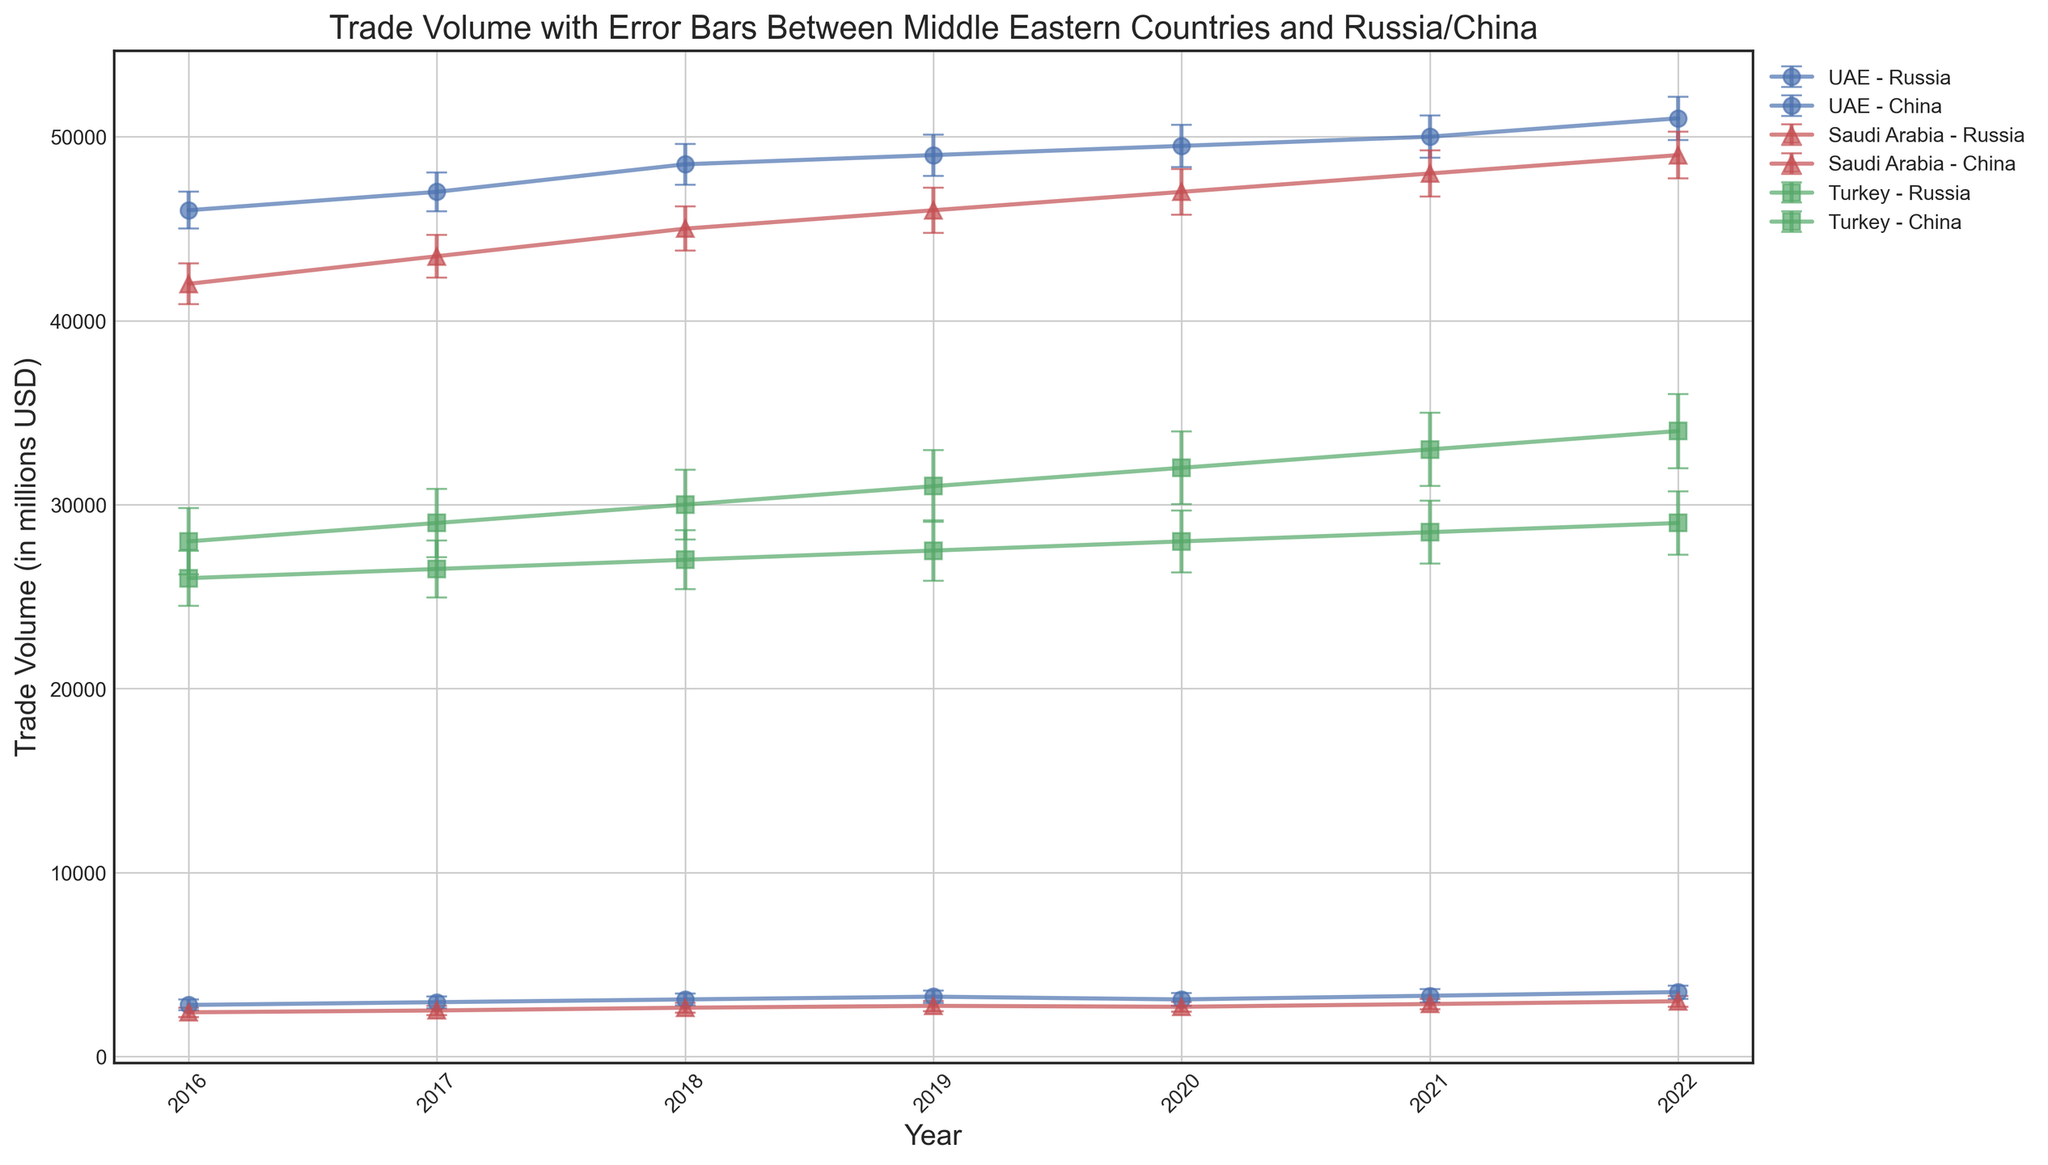Which country showed the largest trade volume with China in 2019? By inspecting the chart for 2019, we compare the trade volumes with China for UAE, Saudi Arabia, and Turkey. The UAE has around 49,000, Saudi Arabia around 46,000, and Turkey around 31,000. Thus, the UAE showed the largest trade volume with China in 2019.
Answer: UAE How does the trade volume with Russia for Saudi Arabia in 2018 compare to 2022? By comparing the trade volumes for Saudi Arabia and Russia in these years, we see that in 2018 it was around 2,650, whereas in 2022 it was around 3,000. This means there was an increase of approximately 350.
Answer: Increase by 350 What is the total trade volume between Turkey and both partners (Russia and China) in 2020? Inspect the chart for Turkey in 2020. The trade volumes with Russia and China were about 28,000 and 32,000 respectively. Summing these gives a total of 28,000 + 32,000 = 60,000.
Answer: 60,000 Which country had the smallest error margin in trading with Russia in 2021? Check the error bars for UAE, Saudi Arabia, and Turkey trading with Russia in 2021. The smallest error bar appears to be Saudi Arabia with an error margin of around 290.
Answer: Saudi Arabia During which year did UAE's trade volume with Russia reach its highest value within the given dataset? By observing the UAE's trade volumes with Russia across the years, the highest volume appears in 2022 with around 3,500.
Answer: 2022 What is the average trade volume for Saudi Arabia with China from 2016 to 2022? Calculate the average by summing the trade volumes from 2016 to 2022 (42,000 + 43,500 + 45,000 + 46,000 + 47,000 + 48,000 + 49,000) and dividing by the number of years (7). The total is 320,500, so the average is 320,500 / 7 = 45,785.71.
Answer: 45,785.71 How does the trend in trade volume between UAE and China compare to that between UAE and Russia from 2016 to 2022? Analyze the trends for both UAE-China and UAE-Russia. UAE-China shows a consistently increasing trend from 46,000 to 51,000, while UAE-Russia also shows an increasing trend but starts much lower at 2,800 and reaches 3,500. Both trends are upward, but the magnitude of trade volume with China is significantly higher.
Answer: Both increase; trade with China is higher Which country showed more stability in trade volume with Russia, considering the error bars, between 2016 and 2022? By examining the error bars for UAE, Saudi Arabia, and Turkey with Russia, Saudi Arabia consistently has smaller error margins compared to UAE and Turkey. This suggests more stability.
Answer: Saudi Arabia What is the difference in trade volume between Turkey and China in 2020 compared to 2022? In 2020, Turkey's trade volume with China was about 32,000, and in 2022 it was about 34,000. The difference is 34,000 - 32,000 = 2,000.
Answer: 2,000 